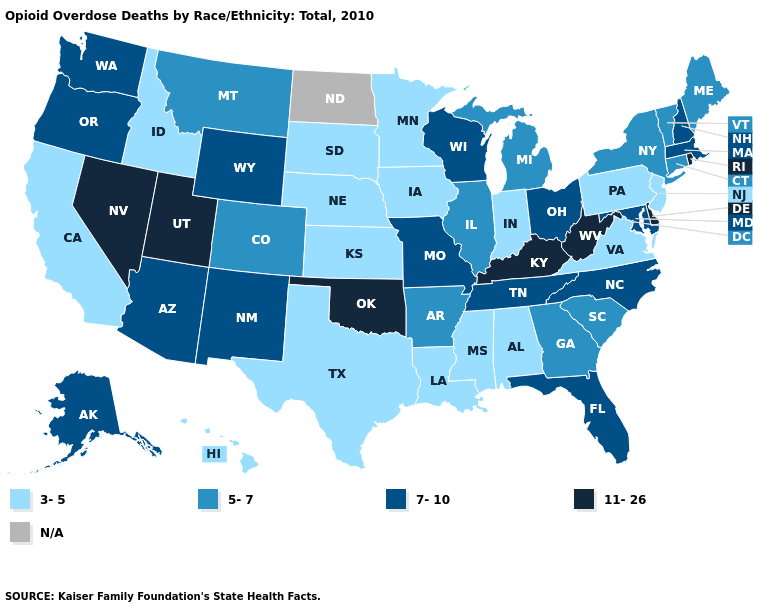Among the states that border Tennessee , which have the highest value?
Give a very brief answer. Kentucky. Which states have the lowest value in the USA?
Short answer required. Alabama, California, Hawaii, Idaho, Indiana, Iowa, Kansas, Louisiana, Minnesota, Mississippi, Nebraska, New Jersey, Pennsylvania, South Dakota, Texas, Virginia. What is the value of Illinois?
Answer briefly. 5-7. Name the states that have a value in the range 3-5?
Keep it brief. Alabama, California, Hawaii, Idaho, Indiana, Iowa, Kansas, Louisiana, Minnesota, Mississippi, Nebraska, New Jersey, Pennsylvania, South Dakota, Texas, Virginia. Which states hav the highest value in the MidWest?
Answer briefly. Missouri, Ohio, Wisconsin. What is the value of Massachusetts?
Give a very brief answer. 7-10. Among the states that border New York , does Pennsylvania have the lowest value?
Concise answer only. Yes. Which states have the lowest value in the USA?
Keep it brief. Alabama, California, Hawaii, Idaho, Indiana, Iowa, Kansas, Louisiana, Minnesota, Mississippi, Nebraska, New Jersey, Pennsylvania, South Dakota, Texas, Virginia. Name the states that have a value in the range 5-7?
Answer briefly. Arkansas, Colorado, Connecticut, Georgia, Illinois, Maine, Michigan, Montana, New York, South Carolina, Vermont. Name the states that have a value in the range 7-10?
Quick response, please. Alaska, Arizona, Florida, Maryland, Massachusetts, Missouri, New Hampshire, New Mexico, North Carolina, Ohio, Oregon, Tennessee, Washington, Wisconsin, Wyoming. What is the value of New Mexico?
Concise answer only. 7-10. Name the states that have a value in the range 7-10?
Concise answer only. Alaska, Arizona, Florida, Maryland, Massachusetts, Missouri, New Hampshire, New Mexico, North Carolina, Ohio, Oregon, Tennessee, Washington, Wisconsin, Wyoming. What is the value of Florida?
Short answer required. 7-10. 